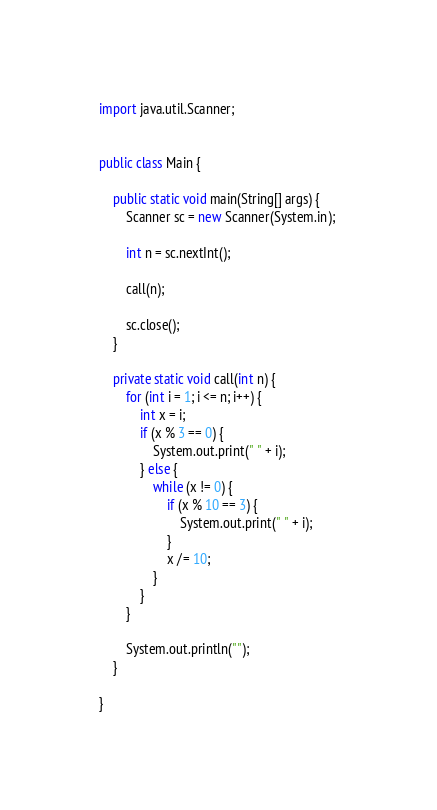<code> <loc_0><loc_0><loc_500><loc_500><_Java_>import java.util.Scanner;


public class Main {

	public static void main(String[] args) {
		Scanner sc = new Scanner(System.in); 

		int n = sc.nextInt();

		call(n);

		sc.close();
	}

	private static void call(int n) {
		for (int i = 1; i <= n; i++) {
			int x = i;
			if (x % 3 == 0) {
				System.out.print(" " + i);
			} else {
				while (x != 0) {
					if (x % 10 == 3) {
						System.out.print(" " + i);
					}
					x /= 10;
				}					
			}
		}

		System.out.println("");
	}

}</code> 